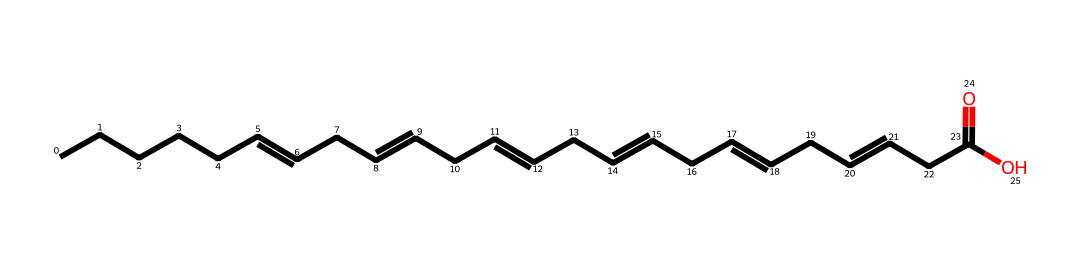What is the molecular formula of this chemical? To find the molecular formula, we identify the number of each type of atom in the SMILES representation. This structure consists of carbon (C), hydrogen (H), and oxygen (O). Counting the carbon atoms shows 18, while the oxygen atoms count is 2. The total number of hydrogen atoms can be calculated based on the hydrogen saturation rule for fully saturated hydrocarbons, leading to the conclusion of 34 hydrogen atoms. Thus, the molecular formula is C18H34O2.
Answer: C18H34O2 How many double bonds are present in this structure? The SMILES representation contains the "=" symbol, which indicates double bonds. By analyzing the structure, we find four instances where double bonds are specified. Therefore, there are four double bonds present in this fatty acid.
Answer: 4 What type of fatty acid is represented by this structure? The chemical structure is indicative of an unsaturated fatty acid, specifically omega-3 fatty acid, due to the presence of multiple double bonds and the functional group present. Omega-3 fatty acids are characterized by their position of the first double bond near the terminal methyl group.
Answer: omega-3 How many total carbon atoms connect to the functional group? The functional group in this SMILES notation is the carboxylic acid (-COOH) at the end of the chain. The carbon chain has a total of 18 carbon atoms, and the carboxylic carbon is counted as part of this, meaning that there are 17 carbon atoms connecting to the functional group.
Answer: 17 Which part of the chemical is responsible for its potential benefits on brain health? The omega-3 fatty acids feature multiple double bonds, particularly the first one closest to the methyl end of the chain, which is crucial for maintaining fluidity in cell membranes. These properties are linked to neuroprotective effects and improvement in cognitive functions. Hence, the unsaturation in the fatty acid chains is key to its brain health benefits.
Answer: unsaturation 